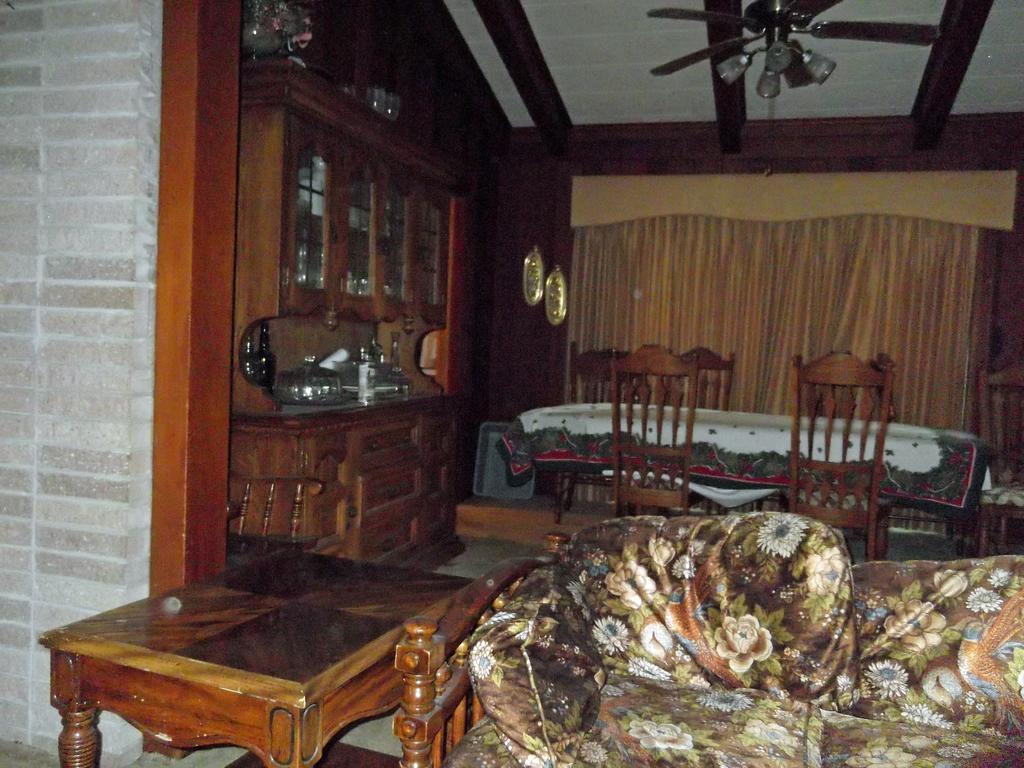Please provide a concise description of this image. This picture shows the inner view of a building. There is one fan with lights attached to the ceiling, so many objects are in the wooden cupboards, one big curtain, one table, some objects hanged on the wall, one dining table covered with a table cloth, one sofa, so many chairs around the dining table. 